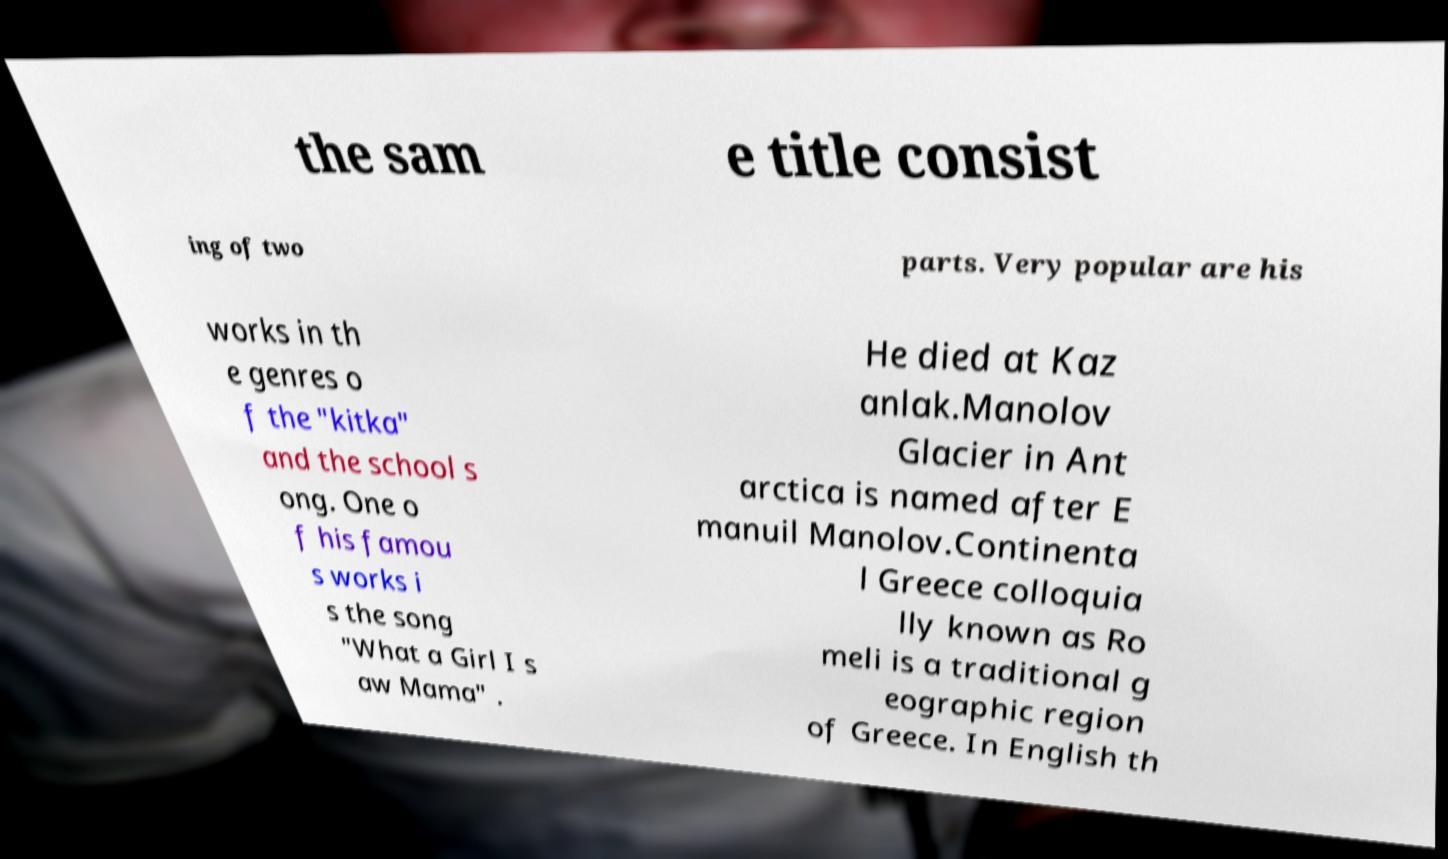Could you assist in decoding the text presented in this image and type it out clearly? the sam e title consist ing of two parts. Very popular are his works in th e genres o f the "kitka" and the school s ong. One o f his famou s works i s the song "What a Girl I s aw Mama" . He died at Kaz anlak.Manolov Glacier in Ant arctica is named after E manuil Manolov.Continenta l Greece colloquia lly known as Ro meli is a traditional g eographic region of Greece. In English th 